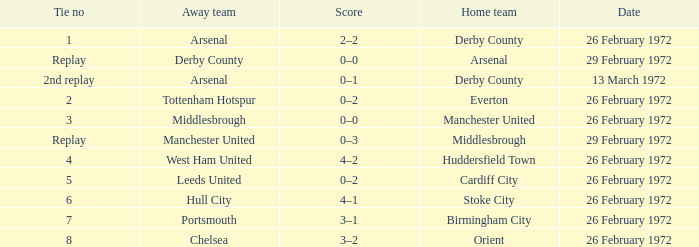Which Tie is from birmingham city? 7.0. 